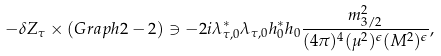<formula> <loc_0><loc_0><loc_500><loc_500>- \delta Z _ { \tau } \times ( { \sl G r a p h 2 - 2 } \/ ) \ni - 2 i \lambda _ { \tau , 0 } ^ { * } \lambda _ { \tau , 0 } h _ { 0 } ^ { * } h _ { 0 } \frac { m _ { 3 / 2 } ^ { 2 } } { ( 4 \pi ) ^ { 4 } ( \mu ^ { 2 } ) ^ { \epsilon } ( M ^ { 2 } ) ^ { \epsilon } } ,</formula> 